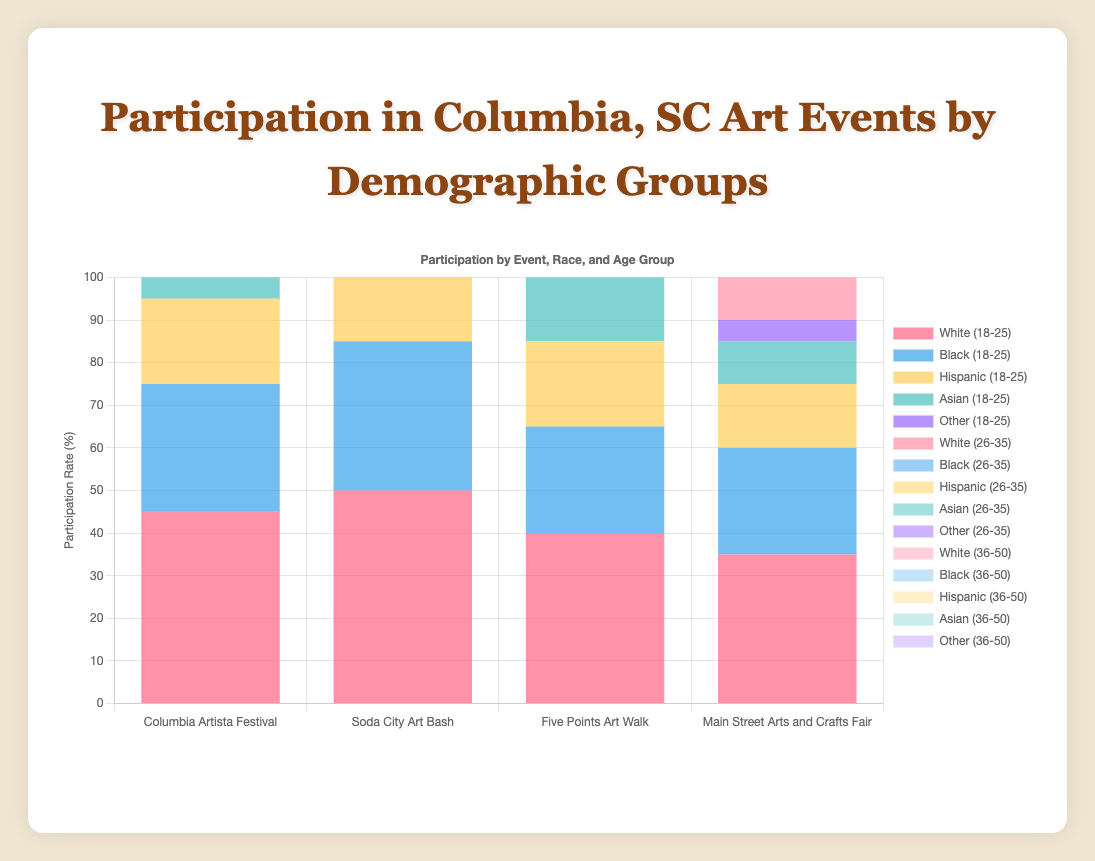What is the participation rate for the Hispanic (18-25) demographic at the Columbia Artista Festival? The chart shows the participation rate for the Hispanic (18-25) demographic in different events. For the Columbia Artista Festival, the bar corresponding to Hispanic (18-25) is 20%.
Answer: 20% How does the participation of Black (26-35) compare between the Soda City Art Bash and the Main Street Arts and Crafts Fair? To find this, look at the height of the bars for Black (26-35) in both events. The height of the bar for Soda City Art Bash is 40%, whereas, for the Main Street Arts and Crafts Fair, it is 30%. Soda City Art Bash has a higher participation rate.
Answer: Soda City Art Bash: 40%, Main Street Arts and Crafts Fair: 30% Which demographic has the highest participation rate at the Five Points Art Walk? To determine this, compare the heights of all demographic bars for the Five Points Art Walk. The highest bar belongs to White (36-50) with 60%.
Answer: White (36-50) What is the total participation rate for the White demographic group across all age groups at the Soda City Art Bash? Sum the participation rates of the White demographic across all age groups at the Soda City Art Bash: 50 (18-25) + 60 (26-35) + 70 (36-50) = 180%.
Answer: 180% How does the participation of the Asian (26-35) demographic compare between the Columbia Artista Festival and the Five Points Art Walk? Locate the participation rate bars for the Asian (26-35) demographic at both events. For the Columbia Artista Festival, the rate is 20%, and for the Five Points Art Walk, it is also 20%. The participation rates are equal.
Answer: Equal, both 20% What event has the lowest participation rate for the White (18-25) demographic? Compare the height of the bars for the White (18-25) demographic across all events. The Main Street Arts and Crafts Fair has the lowest participation rate with 35%.
Answer: Main Street Arts and Crafts Fair What is the difference in participation rates for the Black (36-50) demographic between the Soda City Art Bash and the Columbia Artista Festival? Look at the participation rates for Black (36-50) in both events: Soda City Art Bash is 45%, Columbia Artista Festival is 40%. The difference is 45 - 40 = 5%.
Answer: 5% Which demographic group has a higher participation at the Main Street Arts and Crafts Fair: Black (26-35) or Hispanic (36-50)? Compare the heights of the respective bars at the Main Street Arts and Crafts Fair. Black (26-35) has 30% and Hispanic (36-50) has 25%. Black (26-35) has a higher participation rate.
Answer: Black (26-35) What is the average participation rate of the Asian demographic across all events for the age group 18-25? Calculate the average by summing the participation rates for Asian (18-25) across all events and dividing by the number of events: (15 + 20 + 15 + 10) / 4 = 60 / 4 = 15%.
Answer: 15% 